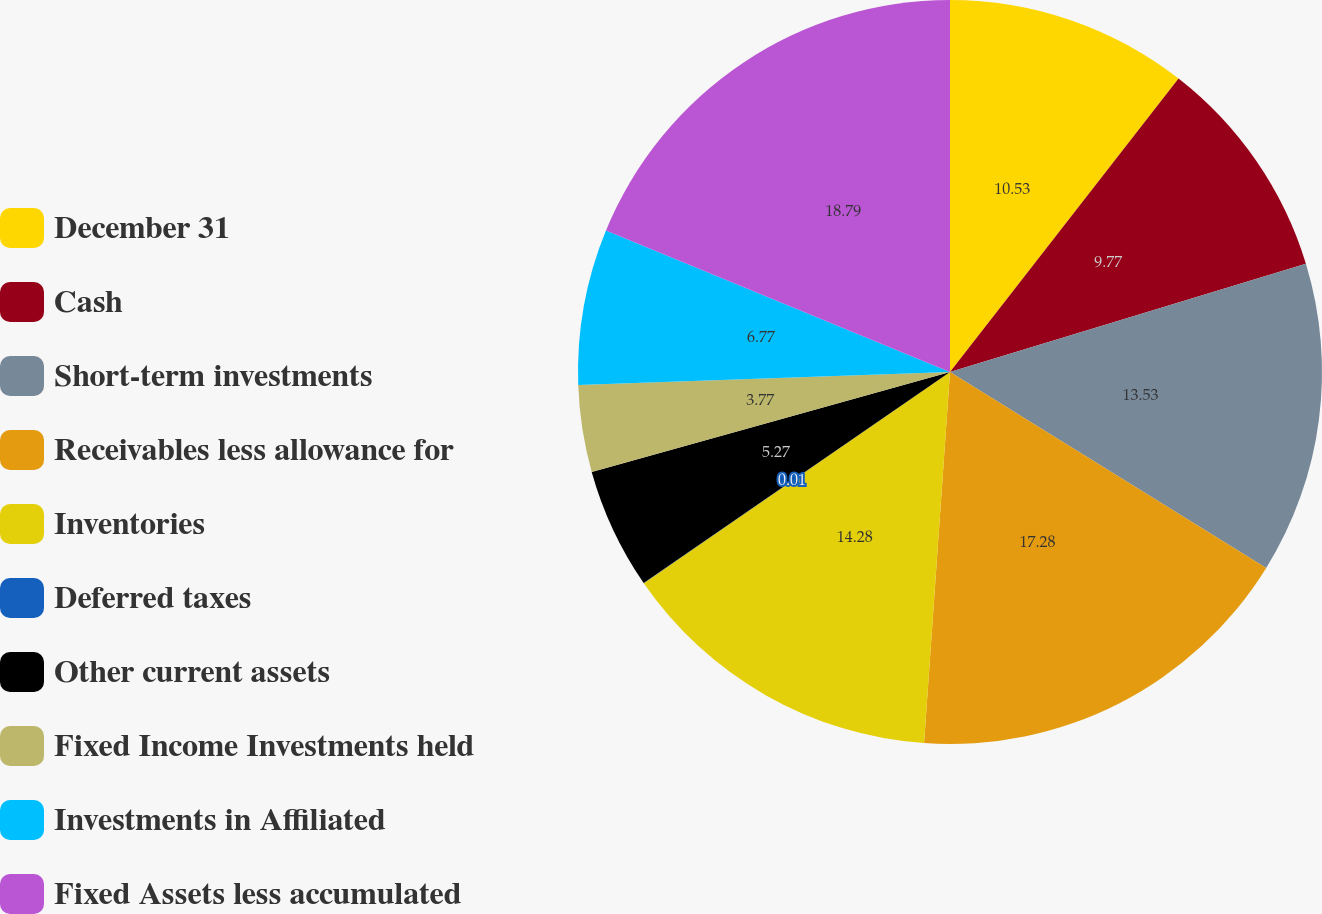<chart> <loc_0><loc_0><loc_500><loc_500><pie_chart><fcel>December 31<fcel>Cash<fcel>Short-term investments<fcel>Receivables less allowance for<fcel>Inventories<fcel>Deferred taxes<fcel>Other current assets<fcel>Fixed Income Investments held<fcel>Investments in Affiliated<fcel>Fixed Assets less accumulated<nl><fcel>10.53%<fcel>9.77%<fcel>13.53%<fcel>17.28%<fcel>14.28%<fcel>0.01%<fcel>5.27%<fcel>3.77%<fcel>6.77%<fcel>18.79%<nl></chart> 